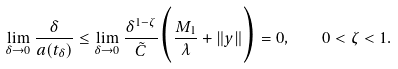Convert formula to latex. <formula><loc_0><loc_0><loc_500><loc_500>\lim _ { \delta \to 0 } \frac { \delta } { a ( t _ { \delta } ) } \leq \lim _ { \delta \to 0 } \frac { \delta ^ { 1 - \zeta } } { \tilde { C } } \Big { ( } \frac { M _ { 1 } } { \lambda } + \| y \| \Big { ) } = 0 , \quad 0 < \zeta < 1 .</formula> 